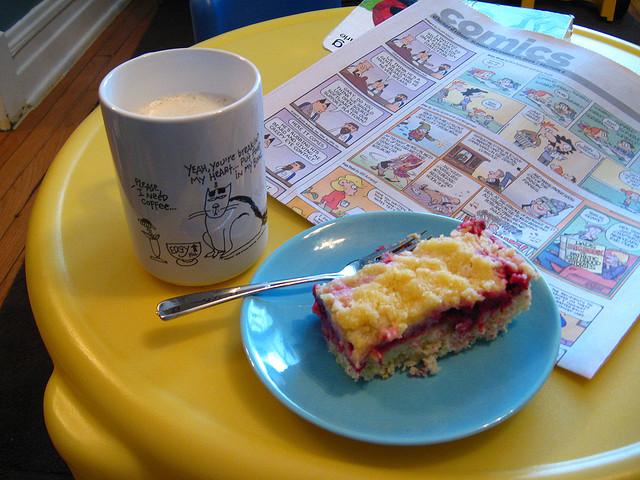Does the cake look delicious?
Quick response, please. Yes. What color is the plate?
Quick response, please. Blue. What utensil is on the plate?
Concise answer only. Fork. How many cups are in the picture?
Short answer required. 1. Is the glass full?
Short answer required. Yes. A type of beverage?
Give a very brief answer. Coffee. How many pieces of food are on the table?
Give a very brief answer. 1. What kind of fruit is this?
Be succinct. Berry. What comic is most left on the page?
Write a very short answer. Dilbert. What color is the cake?
Give a very brief answer. Yellow. Is the letters on the paper in English?
Give a very brief answer. Yes. What kind of ball is on the coffee cup?
Quick response, please. None. What is in the bowl?
Answer briefly. No bowl. Is the cup full?
Answer briefly. Yes. What page of the newspaper is face up?
Give a very brief answer. Comics. Is there milk in the coffee?
Concise answer only. Yes. 